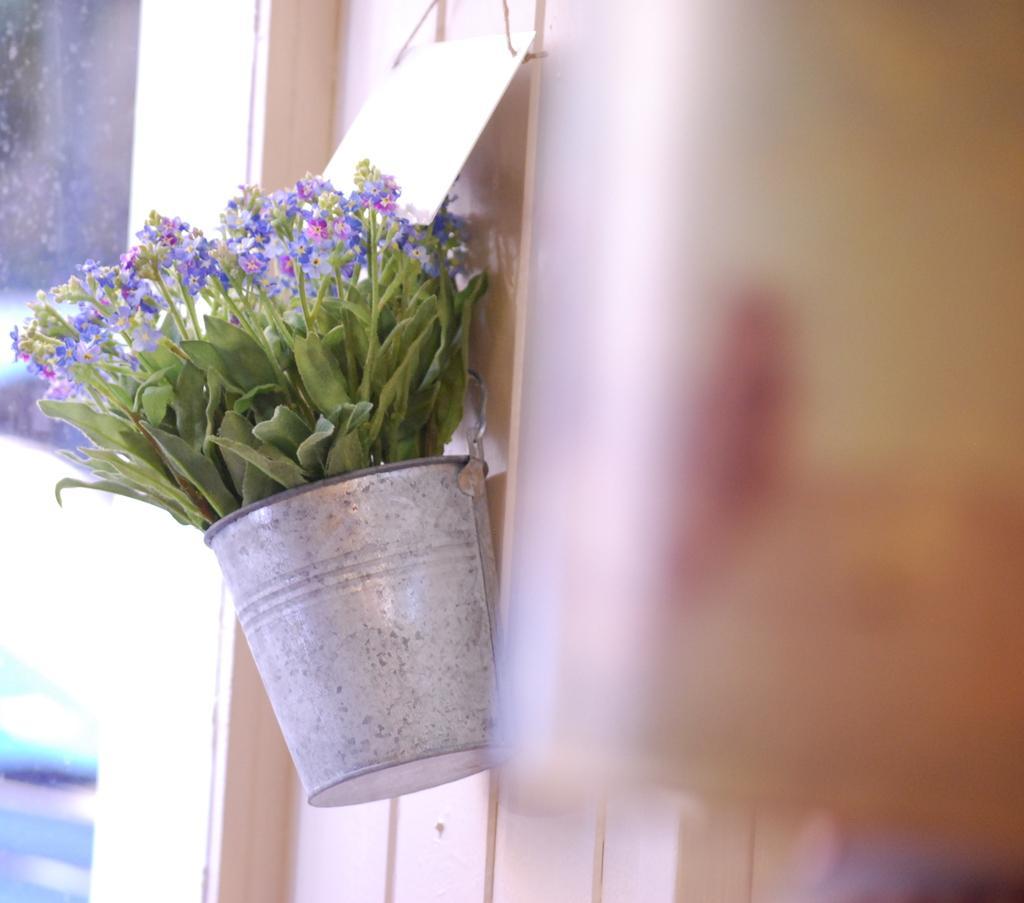Can you describe this image briefly? In this picture we can see some flowers and leaves here, there is a bucket hanging to the wall. 